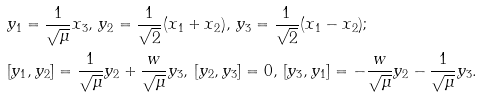<formula> <loc_0><loc_0><loc_500><loc_500>& y _ { 1 } = \frac { 1 } { \sqrt { \mu } } x _ { 3 } , \, y _ { 2 } = \frac { 1 } { \sqrt { 2 } } ( x _ { 1 } + x _ { 2 } ) , \, y _ { 3 } = \frac { 1 } { \sqrt { 2 } } ( x _ { 1 } - x _ { 2 } ) ; \\ & [ y _ { 1 } , y _ { 2 } ] = \frac { 1 } { \sqrt { \mu } } y _ { 2 } + \frac { w } { \sqrt { \mu } } y _ { 3 } , \, [ y _ { 2 } , y _ { 3 } ] = 0 , \, [ y _ { 3 } , y _ { 1 } ] = - \frac { w } { \sqrt { \mu } } y _ { 2 } - \frac { 1 } { \sqrt { \mu } } y _ { 3 } .</formula> 